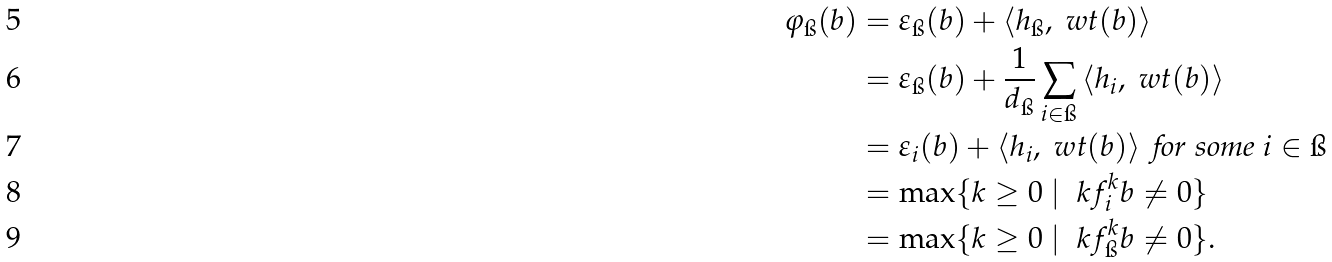Convert formula to latex. <formula><loc_0><loc_0><loc_500><loc_500>\varphi _ { \i } ( b ) & = \varepsilon _ { \i } ( b ) + \left < h _ { \i } , \ w t ( b ) \right > \\ & = \varepsilon _ { \i } ( b ) + \frac { 1 } { d _ { \i } } \sum _ { i \in \i } \left < h _ { i } , \ w t ( b ) \right > \\ & = \varepsilon _ { i } ( b ) + \left < h _ { i } , \ w t ( b ) \right > \text { for some } i \in \i \\ & = \max \{ k \geq 0 \ | \ \ k f _ { i } ^ { k } b \ne 0 \} \\ & = \max \{ k \geq 0 \ | \ \ k f _ { \i } ^ { k } b \ne 0 \} .</formula> 